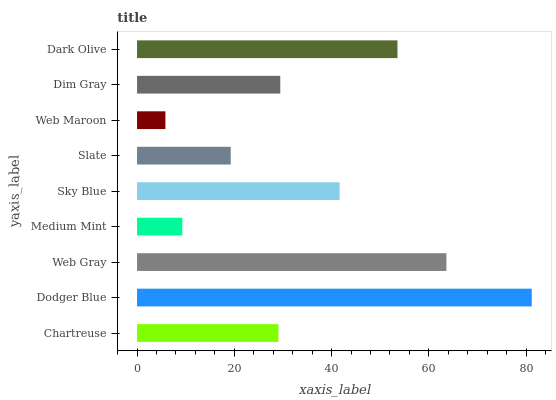Is Web Maroon the minimum?
Answer yes or no. Yes. Is Dodger Blue the maximum?
Answer yes or no. Yes. Is Web Gray the minimum?
Answer yes or no. No. Is Web Gray the maximum?
Answer yes or no. No. Is Dodger Blue greater than Web Gray?
Answer yes or no. Yes. Is Web Gray less than Dodger Blue?
Answer yes or no. Yes. Is Web Gray greater than Dodger Blue?
Answer yes or no. No. Is Dodger Blue less than Web Gray?
Answer yes or no. No. Is Dim Gray the high median?
Answer yes or no. Yes. Is Dim Gray the low median?
Answer yes or no. Yes. Is Slate the high median?
Answer yes or no. No. Is Slate the low median?
Answer yes or no. No. 